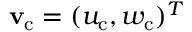<formula> <loc_0><loc_0><loc_500><loc_500>{ v _ { c } } = ( u _ { c } , w _ { c } ) ^ { T }</formula> 